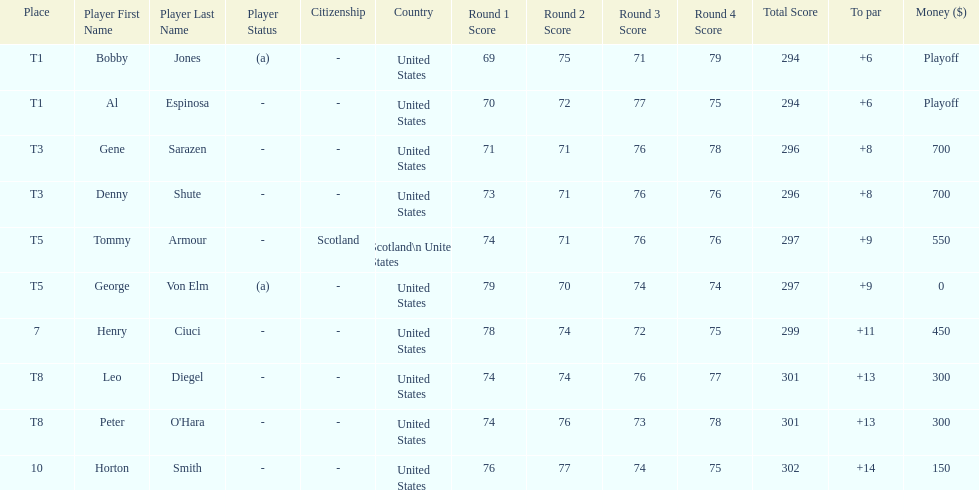How many players represented scotland? 1. 